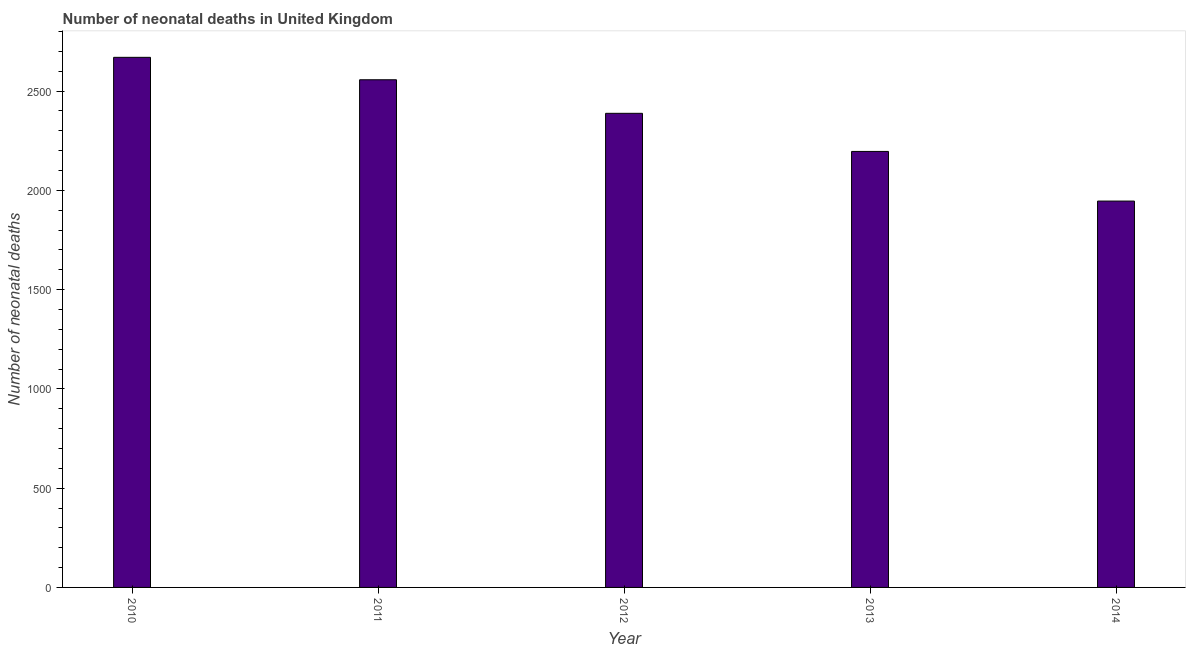What is the title of the graph?
Ensure brevity in your answer.  Number of neonatal deaths in United Kingdom. What is the label or title of the X-axis?
Give a very brief answer. Year. What is the label or title of the Y-axis?
Ensure brevity in your answer.  Number of neonatal deaths. What is the number of neonatal deaths in 2010?
Your answer should be compact. 2670. Across all years, what is the maximum number of neonatal deaths?
Give a very brief answer. 2670. Across all years, what is the minimum number of neonatal deaths?
Give a very brief answer. 1946. In which year was the number of neonatal deaths minimum?
Offer a terse response. 2014. What is the sum of the number of neonatal deaths?
Your response must be concise. 1.18e+04. What is the difference between the number of neonatal deaths in 2012 and 2013?
Provide a short and direct response. 192. What is the average number of neonatal deaths per year?
Provide a short and direct response. 2351. What is the median number of neonatal deaths?
Ensure brevity in your answer.  2388. What is the ratio of the number of neonatal deaths in 2011 to that in 2014?
Keep it short and to the point. 1.31. Is the number of neonatal deaths in 2010 less than that in 2014?
Ensure brevity in your answer.  No. Is the difference between the number of neonatal deaths in 2010 and 2012 greater than the difference between any two years?
Provide a short and direct response. No. What is the difference between the highest and the second highest number of neonatal deaths?
Provide a succinct answer. 113. What is the difference between the highest and the lowest number of neonatal deaths?
Ensure brevity in your answer.  724. In how many years, is the number of neonatal deaths greater than the average number of neonatal deaths taken over all years?
Your response must be concise. 3. How many bars are there?
Make the answer very short. 5. What is the difference between two consecutive major ticks on the Y-axis?
Offer a terse response. 500. What is the Number of neonatal deaths of 2010?
Ensure brevity in your answer.  2670. What is the Number of neonatal deaths in 2011?
Your answer should be very brief. 2557. What is the Number of neonatal deaths in 2012?
Your answer should be compact. 2388. What is the Number of neonatal deaths in 2013?
Give a very brief answer. 2196. What is the Number of neonatal deaths in 2014?
Your answer should be very brief. 1946. What is the difference between the Number of neonatal deaths in 2010 and 2011?
Your response must be concise. 113. What is the difference between the Number of neonatal deaths in 2010 and 2012?
Your answer should be compact. 282. What is the difference between the Number of neonatal deaths in 2010 and 2013?
Make the answer very short. 474. What is the difference between the Number of neonatal deaths in 2010 and 2014?
Ensure brevity in your answer.  724. What is the difference between the Number of neonatal deaths in 2011 and 2012?
Provide a succinct answer. 169. What is the difference between the Number of neonatal deaths in 2011 and 2013?
Your answer should be compact. 361. What is the difference between the Number of neonatal deaths in 2011 and 2014?
Provide a succinct answer. 611. What is the difference between the Number of neonatal deaths in 2012 and 2013?
Ensure brevity in your answer.  192. What is the difference between the Number of neonatal deaths in 2012 and 2014?
Your answer should be compact. 442. What is the difference between the Number of neonatal deaths in 2013 and 2014?
Ensure brevity in your answer.  250. What is the ratio of the Number of neonatal deaths in 2010 to that in 2011?
Keep it short and to the point. 1.04. What is the ratio of the Number of neonatal deaths in 2010 to that in 2012?
Your answer should be very brief. 1.12. What is the ratio of the Number of neonatal deaths in 2010 to that in 2013?
Provide a succinct answer. 1.22. What is the ratio of the Number of neonatal deaths in 2010 to that in 2014?
Offer a terse response. 1.37. What is the ratio of the Number of neonatal deaths in 2011 to that in 2012?
Give a very brief answer. 1.07. What is the ratio of the Number of neonatal deaths in 2011 to that in 2013?
Provide a succinct answer. 1.16. What is the ratio of the Number of neonatal deaths in 2011 to that in 2014?
Offer a very short reply. 1.31. What is the ratio of the Number of neonatal deaths in 2012 to that in 2013?
Offer a very short reply. 1.09. What is the ratio of the Number of neonatal deaths in 2012 to that in 2014?
Offer a terse response. 1.23. What is the ratio of the Number of neonatal deaths in 2013 to that in 2014?
Ensure brevity in your answer.  1.13. 